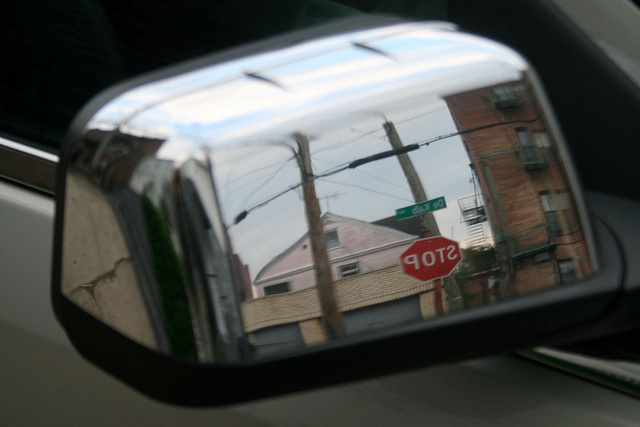Describe the objects in this image and their specific colors. I can see car in black, gray, and darkgray tones and stop sign in black, maroon, gray, and brown tones in this image. 